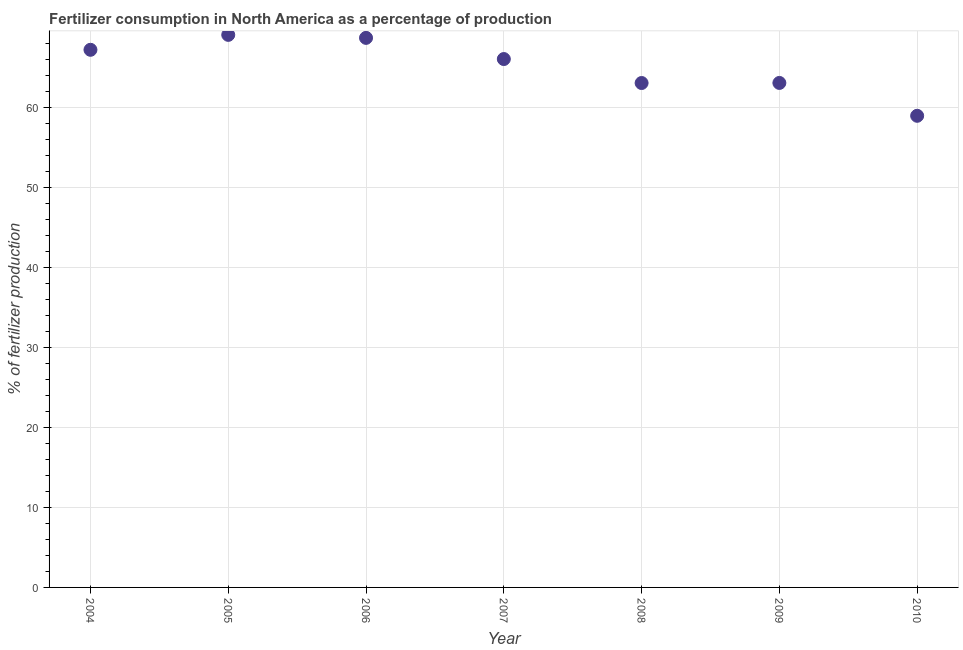What is the amount of fertilizer consumption in 2006?
Your response must be concise. 68.66. Across all years, what is the maximum amount of fertilizer consumption?
Ensure brevity in your answer.  69.04. Across all years, what is the minimum amount of fertilizer consumption?
Your answer should be compact. 58.93. In which year was the amount of fertilizer consumption minimum?
Offer a terse response. 2010. What is the sum of the amount of fertilizer consumption?
Your answer should be very brief. 455.9. What is the difference between the amount of fertilizer consumption in 2006 and 2009?
Provide a short and direct response. 5.63. What is the average amount of fertilizer consumption per year?
Your response must be concise. 65.13. What is the median amount of fertilizer consumption?
Give a very brief answer. 66.02. What is the ratio of the amount of fertilizer consumption in 2004 to that in 2007?
Your response must be concise. 1.02. What is the difference between the highest and the second highest amount of fertilizer consumption?
Your answer should be compact. 0.38. What is the difference between the highest and the lowest amount of fertilizer consumption?
Keep it short and to the point. 10.11. Does the amount of fertilizer consumption monotonically increase over the years?
Provide a succinct answer. No. How many years are there in the graph?
Your answer should be compact. 7. Are the values on the major ticks of Y-axis written in scientific E-notation?
Keep it short and to the point. No. Does the graph contain any zero values?
Your answer should be compact. No. What is the title of the graph?
Your answer should be compact. Fertilizer consumption in North America as a percentage of production. What is the label or title of the Y-axis?
Offer a very short reply. % of fertilizer production. What is the % of fertilizer production in 2004?
Give a very brief answer. 67.18. What is the % of fertilizer production in 2005?
Offer a very short reply. 69.04. What is the % of fertilizer production in 2006?
Make the answer very short. 68.66. What is the % of fertilizer production in 2007?
Make the answer very short. 66.02. What is the % of fertilizer production in 2008?
Ensure brevity in your answer.  63.03. What is the % of fertilizer production in 2009?
Offer a very short reply. 63.04. What is the % of fertilizer production in 2010?
Your response must be concise. 58.93. What is the difference between the % of fertilizer production in 2004 and 2005?
Provide a succinct answer. -1.87. What is the difference between the % of fertilizer production in 2004 and 2006?
Keep it short and to the point. -1.49. What is the difference between the % of fertilizer production in 2004 and 2007?
Ensure brevity in your answer.  1.16. What is the difference between the % of fertilizer production in 2004 and 2008?
Ensure brevity in your answer.  4.15. What is the difference between the % of fertilizer production in 2004 and 2009?
Offer a very short reply. 4.14. What is the difference between the % of fertilizer production in 2004 and 2010?
Your answer should be very brief. 8.25. What is the difference between the % of fertilizer production in 2005 and 2006?
Give a very brief answer. 0.38. What is the difference between the % of fertilizer production in 2005 and 2007?
Offer a very short reply. 3.02. What is the difference between the % of fertilizer production in 2005 and 2008?
Give a very brief answer. 6.02. What is the difference between the % of fertilizer production in 2005 and 2009?
Your answer should be compact. 6.01. What is the difference between the % of fertilizer production in 2005 and 2010?
Provide a succinct answer. 10.11. What is the difference between the % of fertilizer production in 2006 and 2007?
Give a very brief answer. 2.64. What is the difference between the % of fertilizer production in 2006 and 2008?
Ensure brevity in your answer.  5.64. What is the difference between the % of fertilizer production in 2006 and 2009?
Give a very brief answer. 5.63. What is the difference between the % of fertilizer production in 2006 and 2010?
Provide a short and direct response. 9.74. What is the difference between the % of fertilizer production in 2007 and 2008?
Your answer should be compact. 3. What is the difference between the % of fertilizer production in 2007 and 2009?
Provide a succinct answer. 2.99. What is the difference between the % of fertilizer production in 2007 and 2010?
Your response must be concise. 7.09. What is the difference between the % of fertilizer production in 2008 and 2009?
Your answer should be compact. -0.01. What is the difference between the % of fertilizer production in 2008 and 2010?
Provide a short and direct response. 4.1. What is the difference between the % of fertilizer production in 2009 and 2010?
Make the answer very short. 4.11. What is the ratio of the % of fertilizer production in 2004 to that in 2005?
Offer a very short reply. 0.97. What is the ratio of the % of fertilizer production in 2004 to that in 2008?
Ensure brevity in your answer.  1.07. What is the ratio of the % of fertilizer production in 2004 to that in 2009?
Your response must be concise. 1.07. What is the ratio of the % of fertilizer production in 2004 to that in 2010?
Your answer should be compact. 1.14. What is the ratio of the % of fertilizer production in 2005 to that in 2006?
Offer a terse response. 1. What is the ratio of the % of fertilizer production in 2005 to that in 2007?
Offer a very short reply. 1.05. What is the ratio of the % of fertilizer production in 2005 to that in 2008?
Your answer should be compact. 1.09. What is the ratio of the % of fertilizer production in 2005 to that in 2009?
Make the answer very short. 1.09. What is the ratio of the % of fertilizer production in 2005 to that in 2010?
Make the answer very short. 1.17. What is the ratio of the % of fertilizer production in 2006 to that in 2007?
Your answer should be very brief. 1.04. What is the ratio of the % of fertilizer production in 2006 to that in 2008?
Provide a short and direct response. 1.09. What is the ratio of the % of fertilizer production in 2006 to that in 2009?
Provide a short and direct response. 1.09. What is the ratio of the % of fertilizer production in 2006 to that in 2010?
Give a very brief answer. 1.17. What is the ratio of the % of fertilizer production in 2007 to that in 2008?
Provide a succinct answer. 1.05. What is the ratio of the % of fertilizer production in 2007 to that in 2009?
Make the answer very short. 1.05. What is the ratio of the % of fertilizer production in 2007 to that in 2010?
Your answer should be very brief. 1.12. What is the ratio of the % of fertilizer production in 2008 to that in 2009?
Give a very brief answer. 1. What is the ratio of the % of fertilizer production in 2008 to that in 2010?
Keep it short and to the point. 1.07. What is the ratio of the % of fertilizer production in 2009 to that in 2010?
Offer a very short reply. 1.07. 